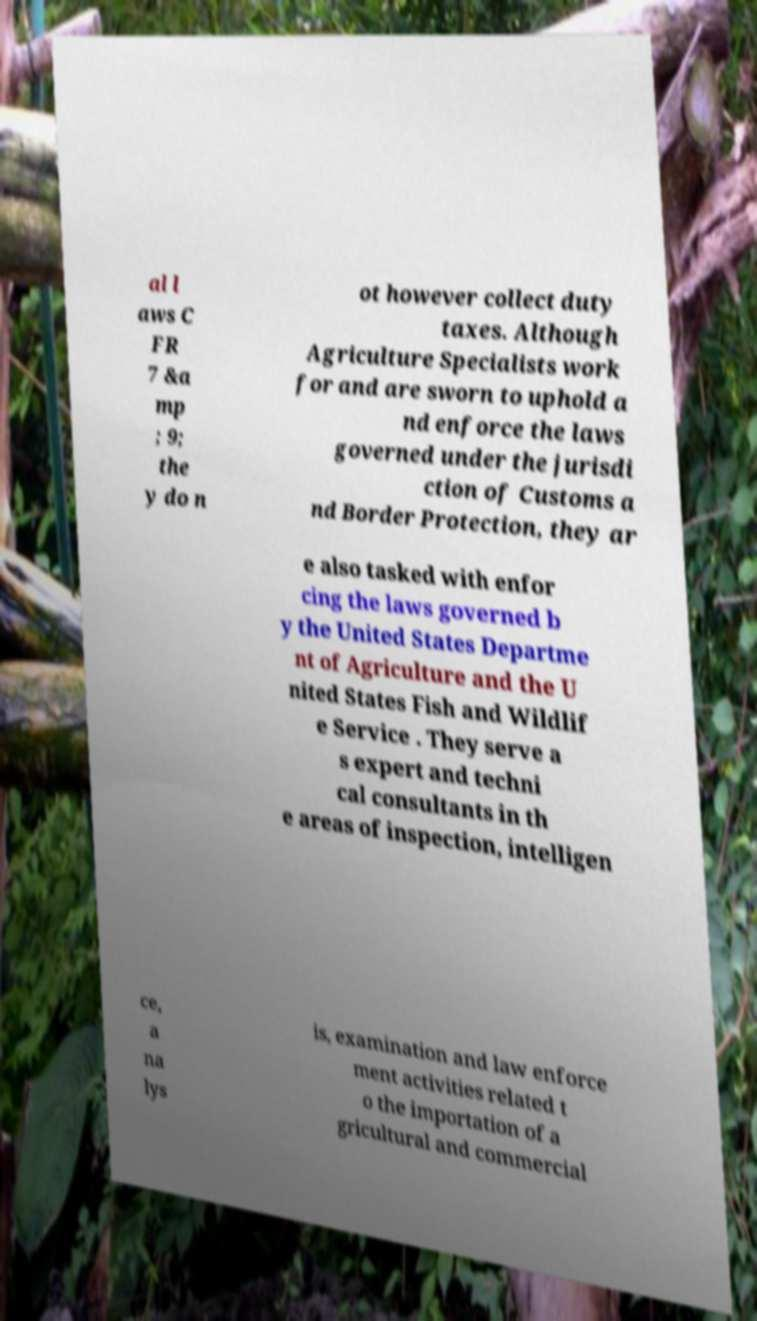What messages or text are displayed in this image? I need them in a readable, typed format. al l aws C FR 7 &a mp ; 9; the y do n ot however collect duty taxes. Although Agriculture Specialists work for and are sworn to uphold a nd enforce the laws governed under the jurisdi ction of Customs a nd Border Protection, they ar e also tasked with enfor cing the laws governed b y the United States Departme nt of Agriculture and the U nited States Fish and Wildlif e Service . They serve a s expert and techni cal consultants in th e areas of inspection, intelligen ce, a na lys is, examination and law enforce ment activities related t o the importation of a gricultural and commercial 